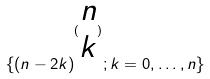<formula> <loc_0><loc_0><loc_500><loc_500>\{ ( n - 2 k ) ^ { ( \begin{matrix} n \\ k \end{matrix} ) } ; k = 0 , \dots , n \}</formula> 